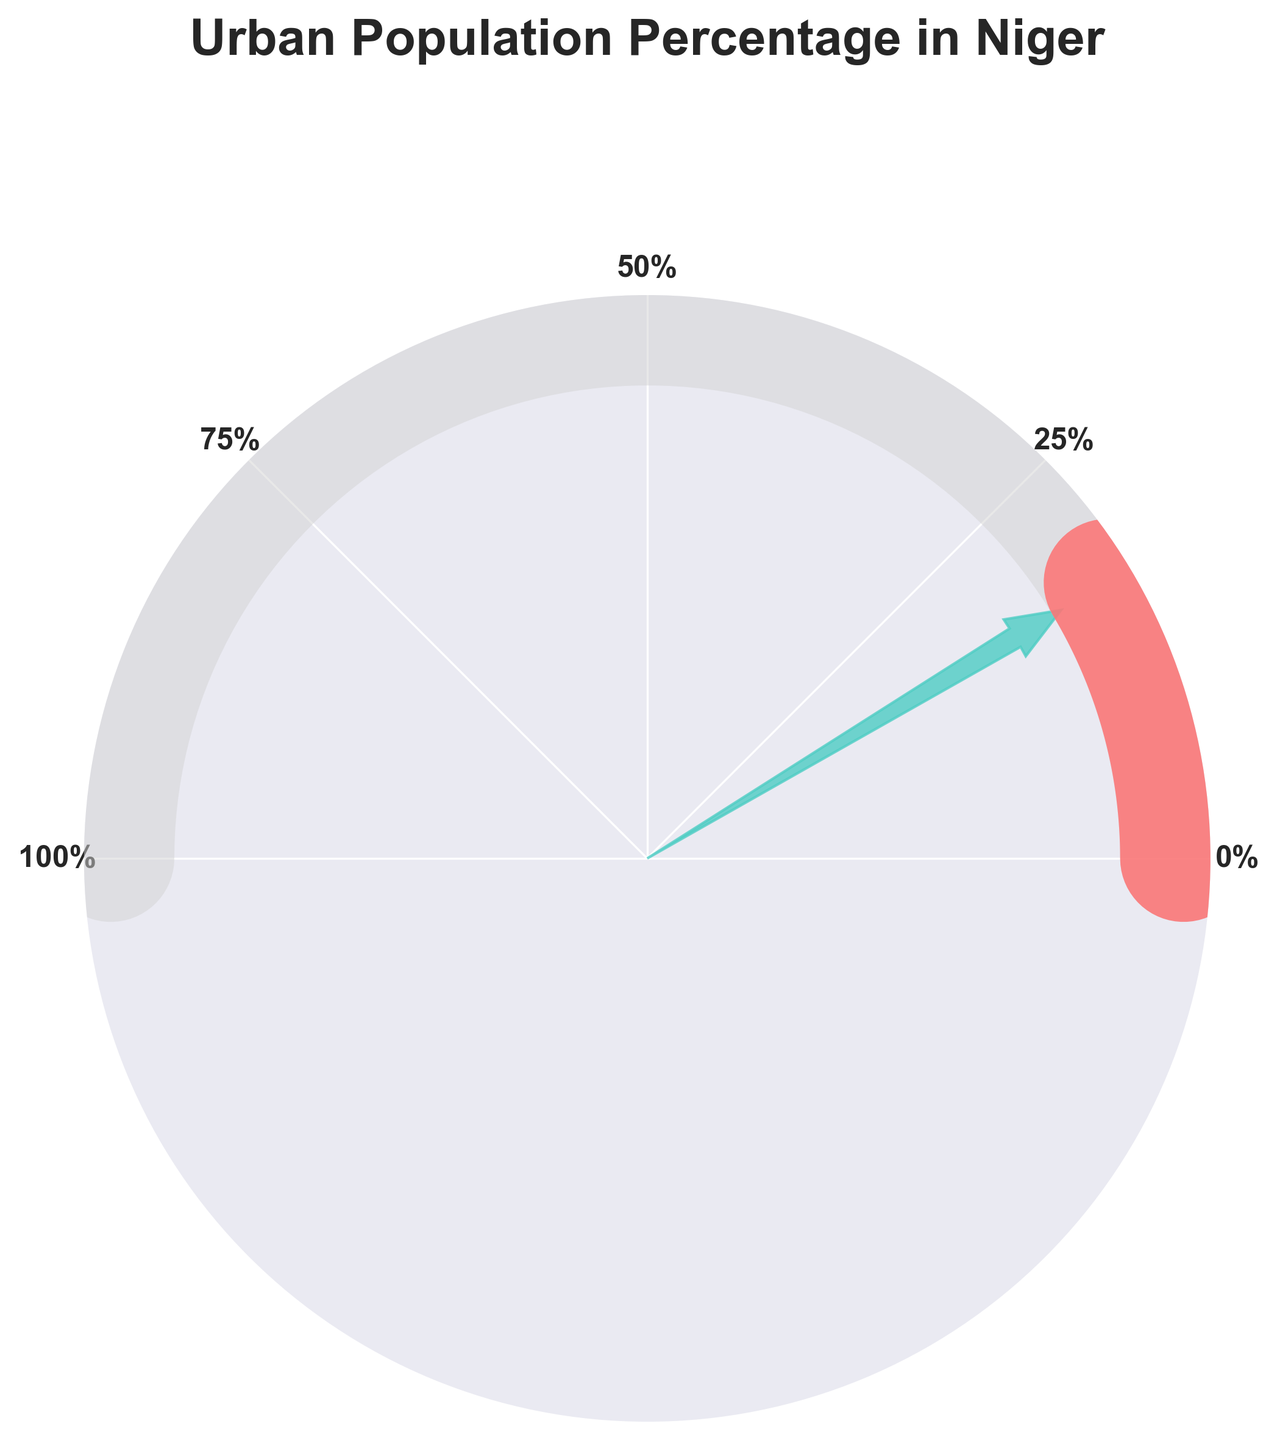What year is the data point with the highest urban population percentage from? The gauge chart shows the percentage of urban population for the latest year, which is displayed explicitly in the text on the chart. The title also states the year. By looking at the text within the chart, we can identify that the highest percentage is from the year 2023.
Answer: 2023 What is the urban population percentage in 2023? The urban population percentage is displayed on the gauge chart and is mentioned explicitly within the text. The number is easy to locate in the center of the chart. By reading this text, you can determine that the urban population percentage in 2023 is 17.2%.
Answer: 17.2% What does the needle on the gauge chart indicate? The needle on the gauge chart points to the urban population percentage of the latest year. It is an indicator showing where the urban population percentage falls within a specified range (0% to 100%). By observing the chart, the needle points to approximately 17.2%, matching the latest urban population percentage.
Answer: 17.2% How has the urban population percentage changed from 2000 to 2023? The urban population percentage in 2000 was 12.7%, and it has increased to 17.2% by 2023. To find the change, we subtract the 2000 percentage from the 2023 percentage: 17.2% - 12.7% = 4.5%. The urban population percentage has increased by 4.5% from 2000 to 2023.
Answer: Increased by 4.5% What are the various color elements used in the gauge chart and what do they represent? The gauge chart uses different colors to convey various elements. The light gray background indicates the gauge framework, the red arc shows the urban population percentage relative to 100%, and the green needle points to the actual percentage value. By observing the elements described above, the chart uses light gray, red, and green as the primary colors.
Answer: Light gray for background, red for percentage arc, green for needle What is the average urban population percentage from 2000 to 2023? To find the average, we sum the percentages for all years and divide by the number of years: (12.7 + 13.5 + 14.4 + 15.4 + 16.5 + 17.2) / 6 = 89.7 / 6. The result is approximately 14.95%.
Answer: 14.95% Based on the gauge chart, what maximum percentage is shown on the gauge? The gauge chart has a scale from 0% to 100%, with the graduation labels at 0%, 25%, 50%, 75%, and 100%. This is visible along the circumference of the gauge.
Answer: 100% Which direction does the needle point in the gauge chart? The needle points towards the right, indicating an angle slightly less than 180 degrees. This direction corresponds to the percentage value for the latest data point, placing the needle around the 17.2% mark.
Answer: Right How does the 2023 urban population percentage compare with that of 2015? Comparing the two values, the urban population percentage in 2023 is 17.2% whereas it was 15.4% in 2015. Therefore, the percentage increased from 2015 to 2023.
Answer: Increased What is the difference in urban population percentage between 2005 and 2020? To find the difference, subtract the 2005 percentage from the 2020 percentage: 16.5% - 13.5% = 3%. Thus, the urban population percentage increased by 3% from 2005 to 2020.
Answer: 3% 